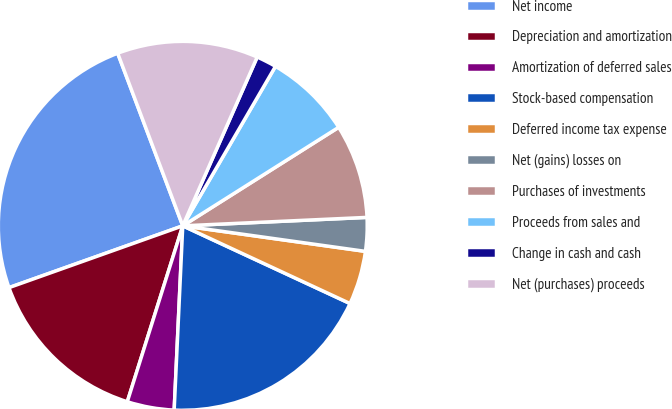<chart> <loc_0><loc_0><loc_500><loc_500><pie_chart><fcel>Net income<fcel>Depreciation and amortization<fcel>Amortization of deferred sales<fcel>Stock-based compensation<fcel>Deferred income tax expense<fcel>Net (gains) losses on<fcel>Purchases of investments<fcel>Proceeds from sales and<fcel>Change in cash and cash<fcel>Net (purchases) proceeds<nl><fcel>24.7%<fcel>14.7%<fcel>4.12%<fcel>18.82%<fcel>4.71%<fcel>2.94%<fcel>8.24%<fcel>7.65%<fcel>1.77%<fcel>12.35%<nl></chart> 